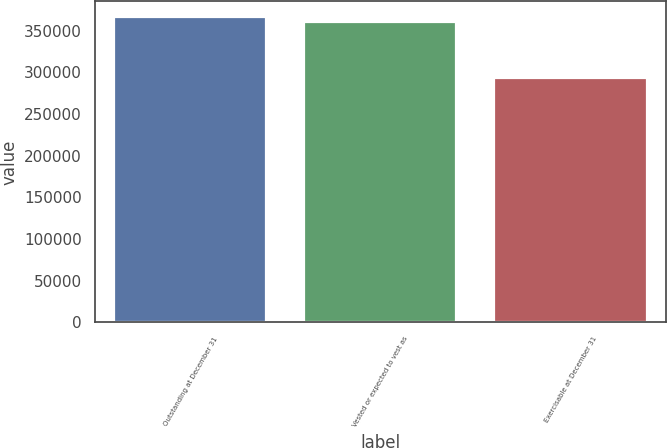Convert chart to OTSL. <chart><loc_0><loc_0><loc_500><loc_500><bar_chart><fcel>Outstanding at December 31<fcel>Vested or expected to vest as<fcel>Exercisable at December 31<nl><fcel>367117<fcel>360329<fcel>293590<nl></chart> 